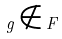<formula> <loc_0><loc_0><loc_500><loc_500>g \notin F</formula> 